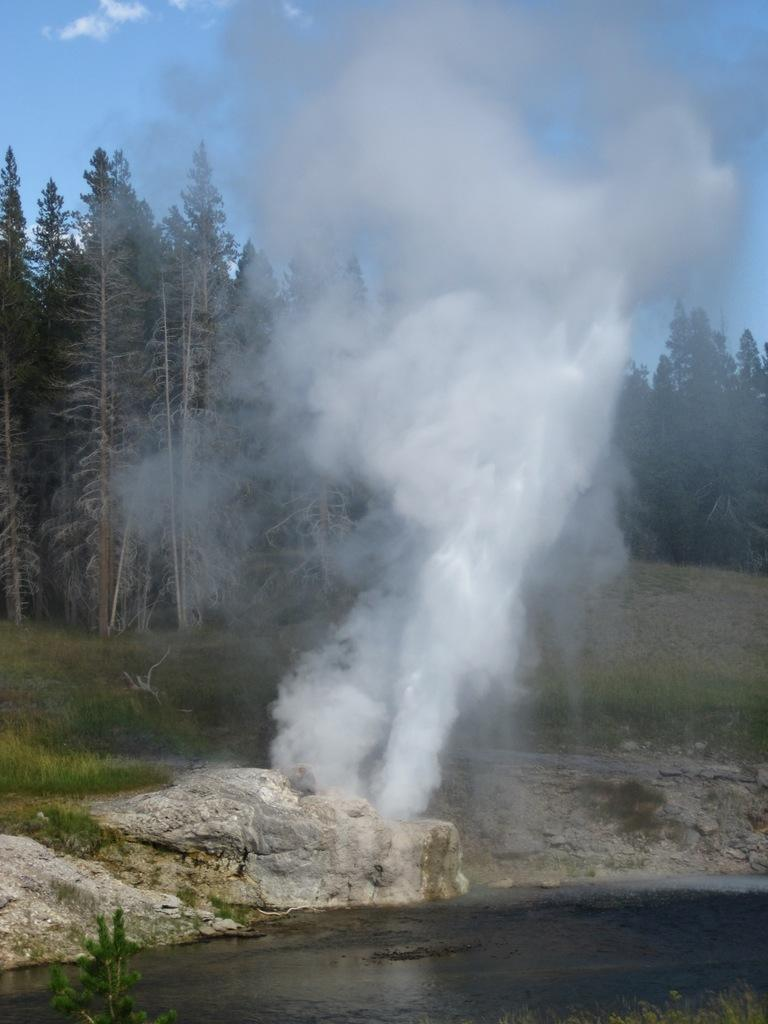What is one of the main elements in the image? There is water in the image. What type of terrain can be seen in the image? There is ground visible in the image. What natural features are present in the image? Rocks and trees are visible in the image. What is the condition of the sky in the image? The sky is visible in the image, and clouds are present in the sky. Is there any evidence of activity in the image? Yes, there is smoke in the image. What type of nut can be seen being cracked by a squirrel in the image? There is no squirrel or nut present in the image. 